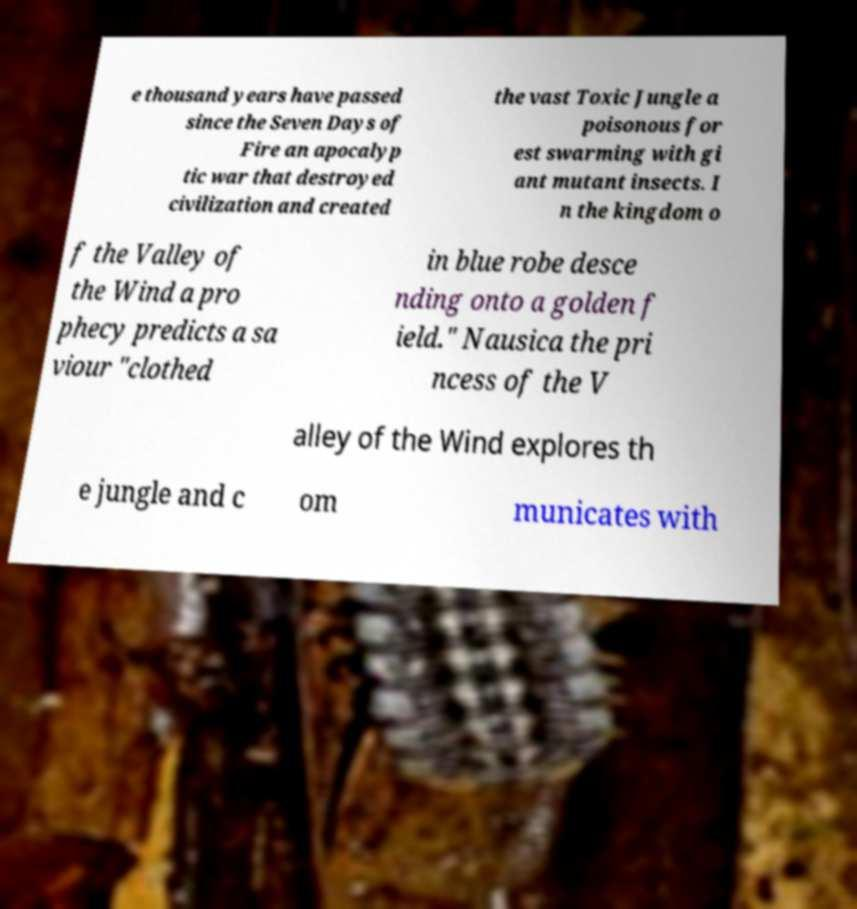I need the written content from this picture converted into text. Can you do that? e thousand years have passed since the Seven Days of Fire an apocalyp tic war that destroyed civilization and created the vast Toxic Jungle a poisonous for est swarming with gi ant mutant insects. I n the kingdom o f the Valley of the Wind a pro phecy predicts a sa viour "clothed in blue robe desce nding onto a golden f ield." Nausica the pri ncess of the V alley of the Wind explores th e jungle and c om municates with 